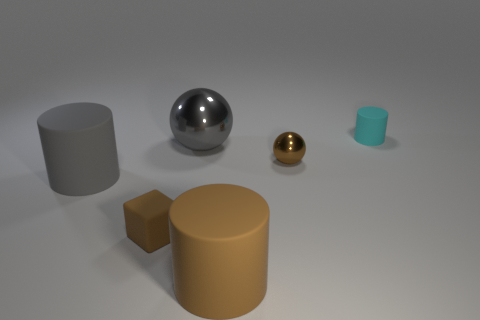Subtract all large cylinders. How many cylinders are left? 1 Add 2 tiny cyan objects. How many objects exist? 8 Subtract all gray balls. How many balls are left? 1 Subtract 2 cylinders. How many cylinders are left? 1 Subtract all cyan cylinders. Subtract all gray matte cylinders. How many objects are left? 4 Add 3 small cyan matte cylinders. How many small cyan matte cylinders are left? 4 Add 4 small brown blocks. How many small brown blocks exist? 5 Subtract 0 purple cylinders. How many objects are left? 6 Subtract all cubes. How many objects are left? 5 Subtract all purple balls. Subtract all red cylinders. How many balls are left? 2 